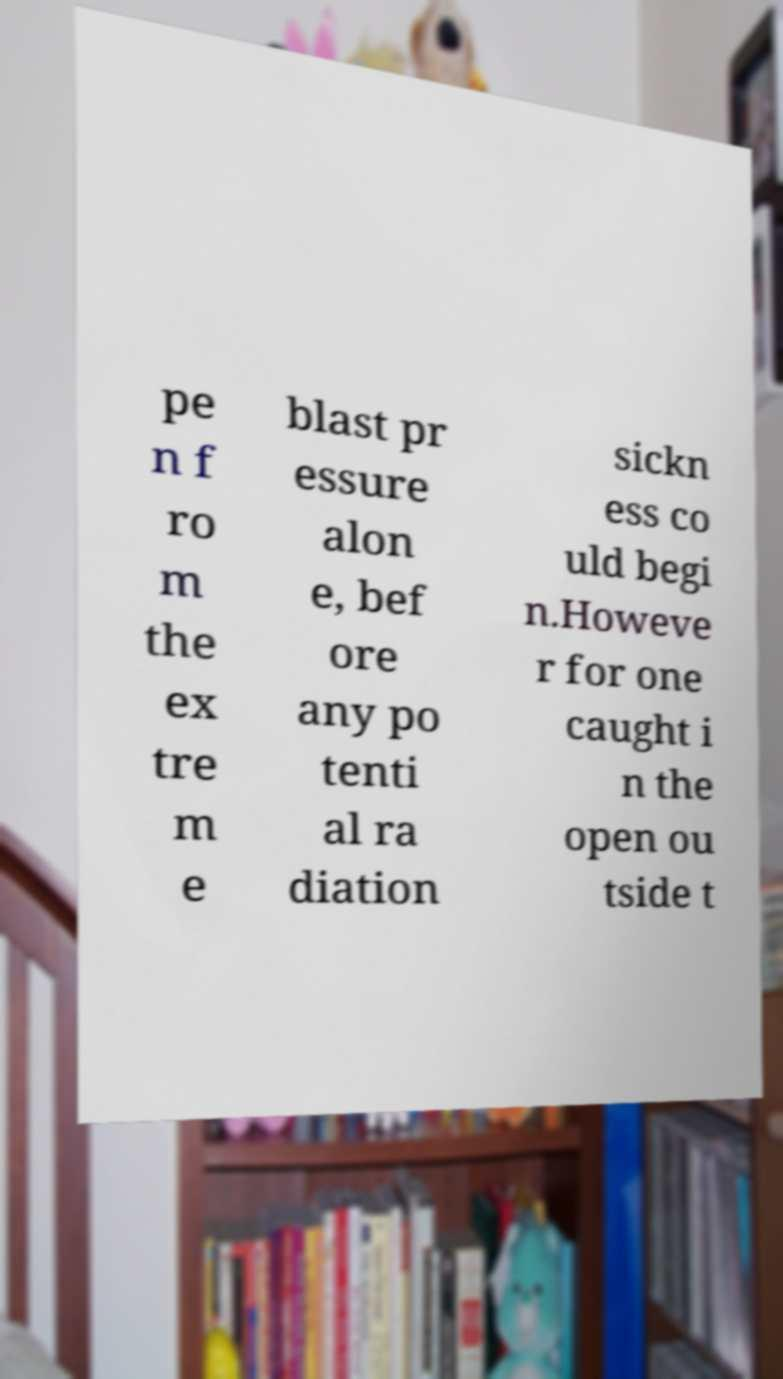There's text embedded in this image that I need extracted. Can you transcribe it verbatim? pe n f ro m the ex tre m e blast pr essure alon e, bef ore any po tenti al ra diation sickn ess co uld begi n.Howeve r for one caught i n the open ou tside t 